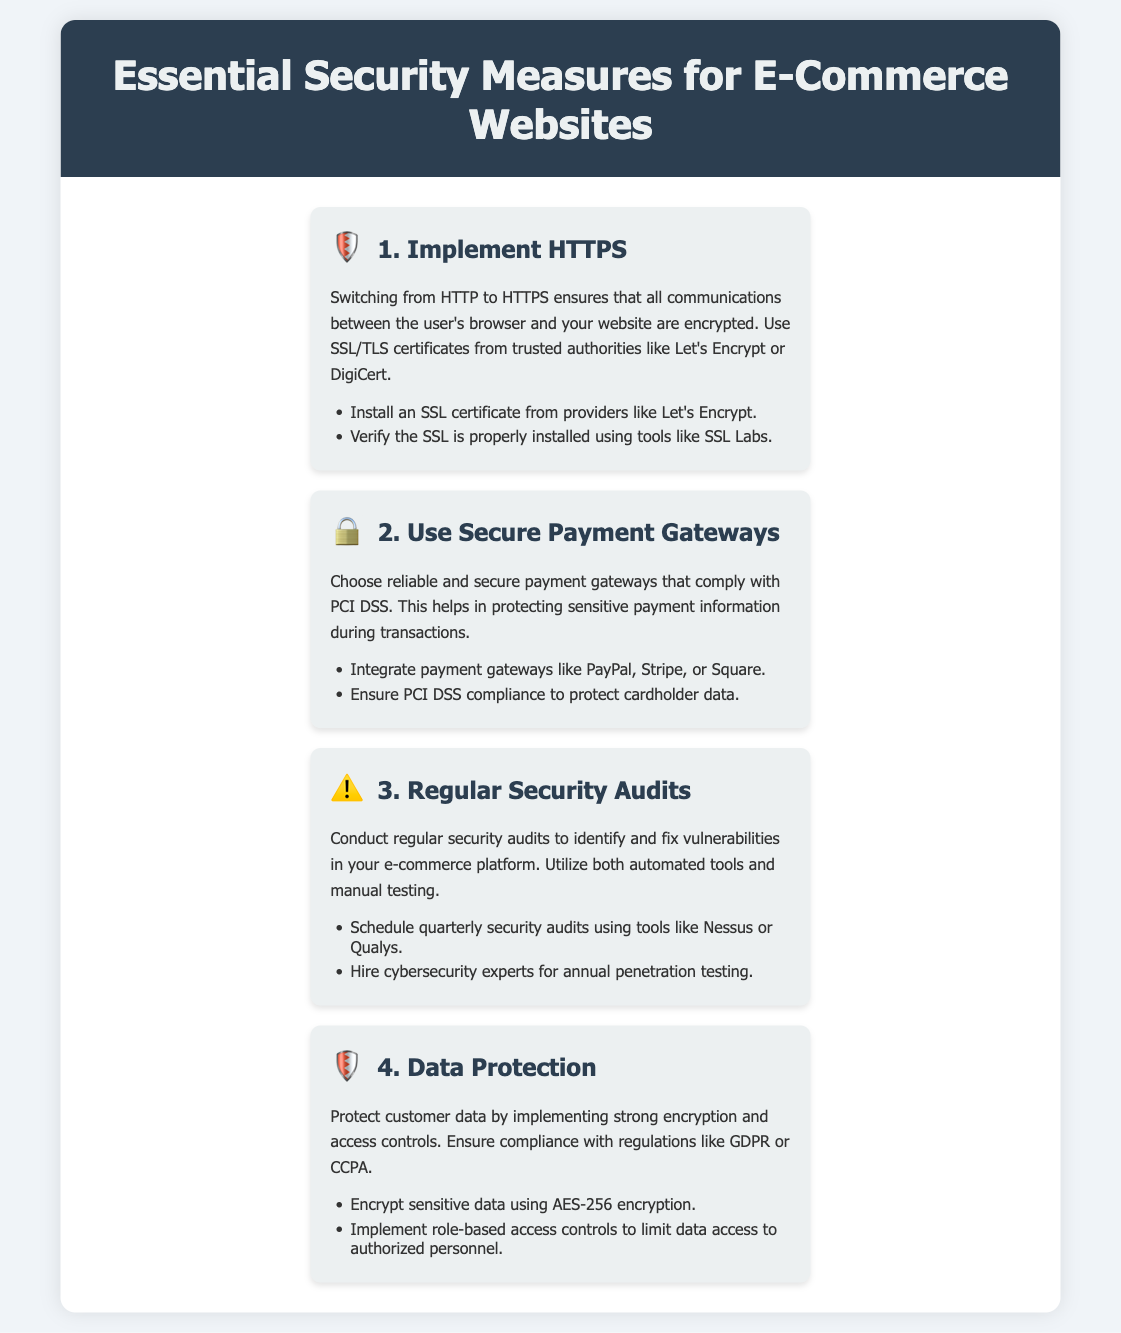What is the first security measure listed? The first security measure outlined in the document is related to HTTPS, which ensures secure communication.
Answer: Implement HTTPS Which icon represents secure payment gateways? The icon used to represent secure payment gateways is a lock symbol.
Answer: 🔒 How often should security audits be conducted? The document suggests conducting security audits quarterly.
Answer: Quarterly What type of encryption is recommended for sensitive data? The recommended encryption method for sensitive data is AES-256 encryption.
Answer: AES-256 What is one benefit of using secure payment gateways? Using secure payment gateways helps in protecting sensitive payment information during transactions.
Answer: Protecting sensitive payment information Which regulatory compliance is mentioned in relation to data protection? The document mentions compliance with GDPR and CCPA for data protection.
Answer: GDPR or CCPA What tool is suggested for verifying SSL installation? SSL Labs is recommended for verifying the proper installation of SSL certificates.
Answer: SSL Labs How many sections are presented in the infographic? The infographic contains four distinct sections that cover various security measures.
Answer: Four 